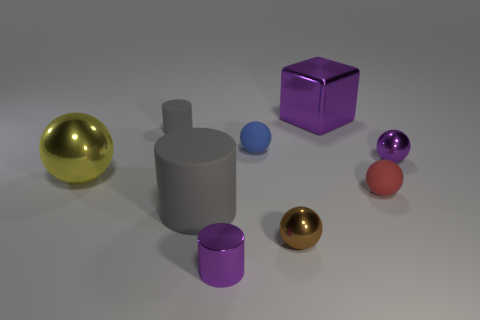What materials seem to make up the various objects in the image? The objects in the image appear to be made of different materials. The shiny gold and silver spheres suggest a metallic finish, while the matte surfaces of the purple cube and cylinder imply a plastic or painted composition. 